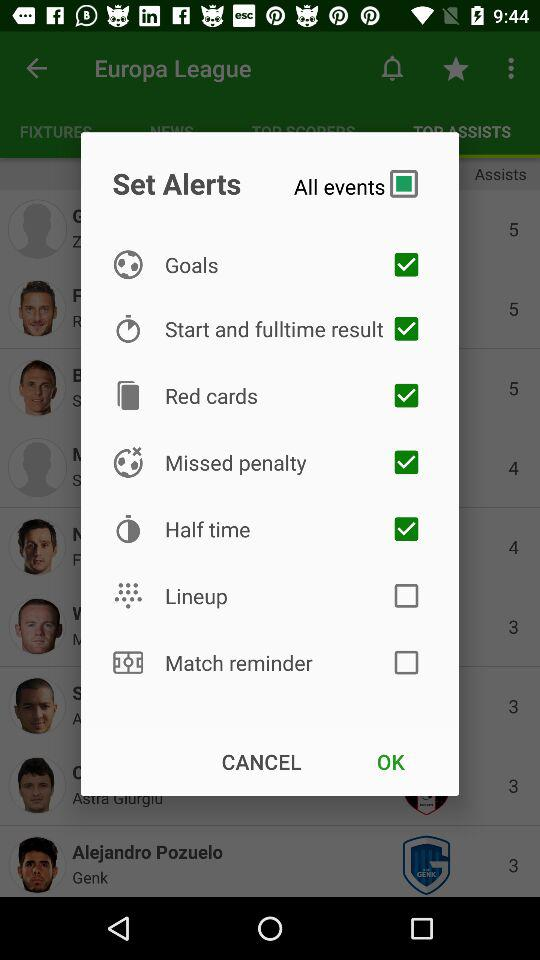For which events alerts were set? The events for which alerts were set are "Goals", "Start and fulltime result", "Red cards", "Missed penalty" and "Half time". 